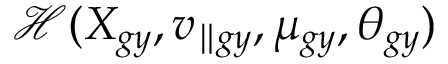Convert formula to latex. <formula><loc_0><loc_0><loc_500><loc_500>\mathcal { H } ( X _ { g y } , v _ { \| g y } , \mu _ { g y } , \theta _ { g y } )</formula> 